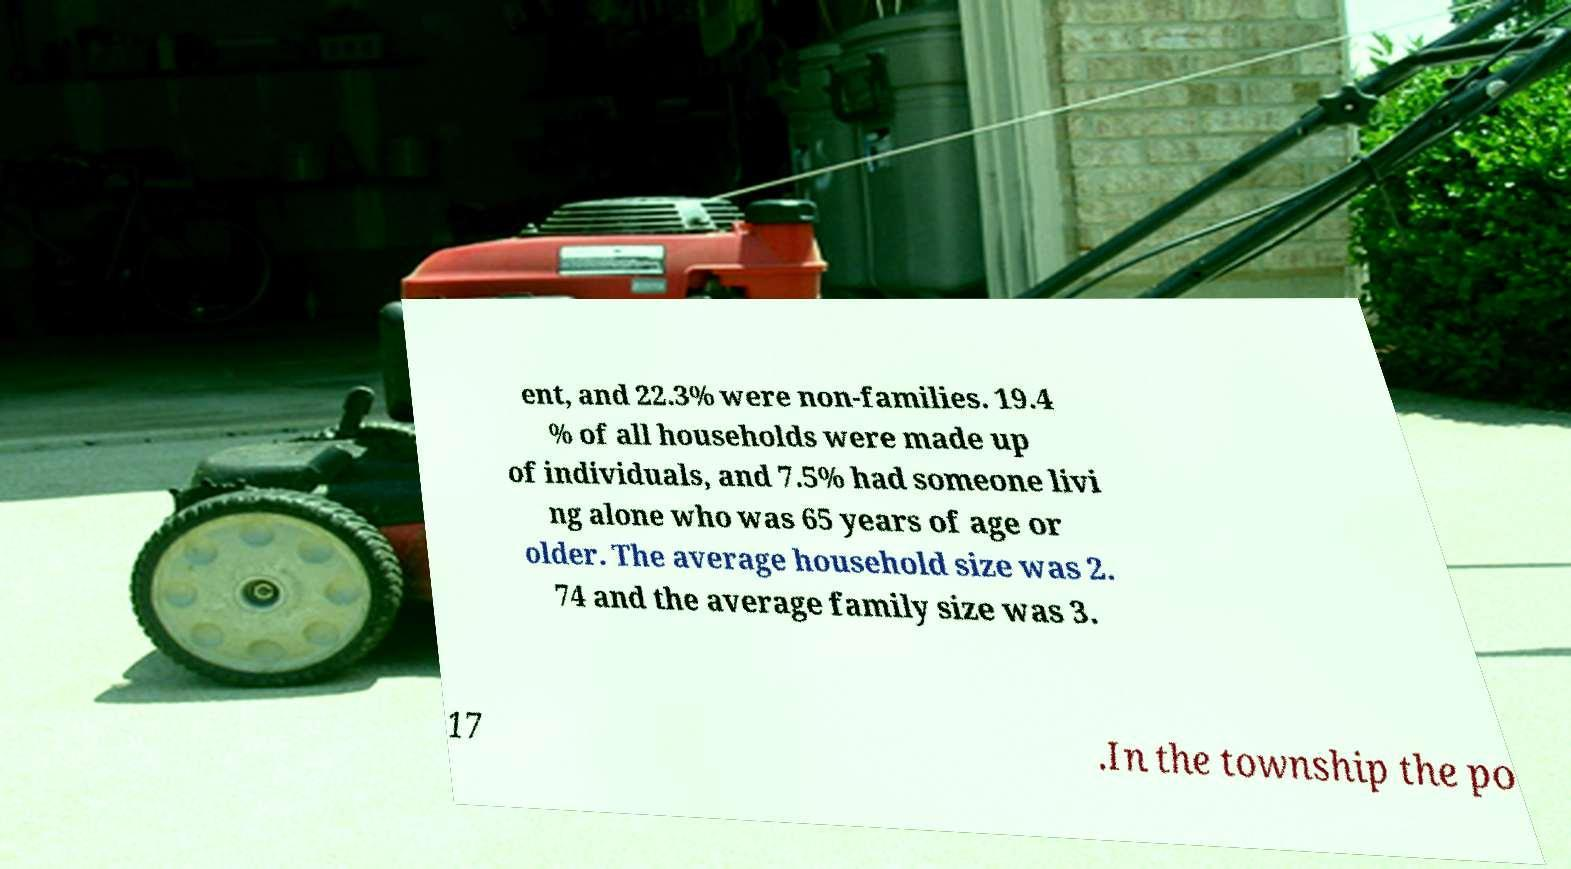What messages or text are displayed in this image? I need them in a readable, typed format. ent, and 22.3% were non-families. 19.4 % of all households were made up of individuals, and 7.5% had someone livi ng alone who was 65 years of age or older. The average household size was 2. 74 and the average family size was 3. 17 .In the township the po 